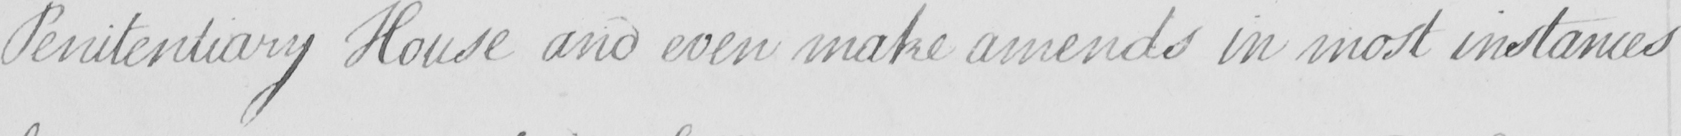What text is written in this handwritten line? Penitentiary House and even make amends in most instances 